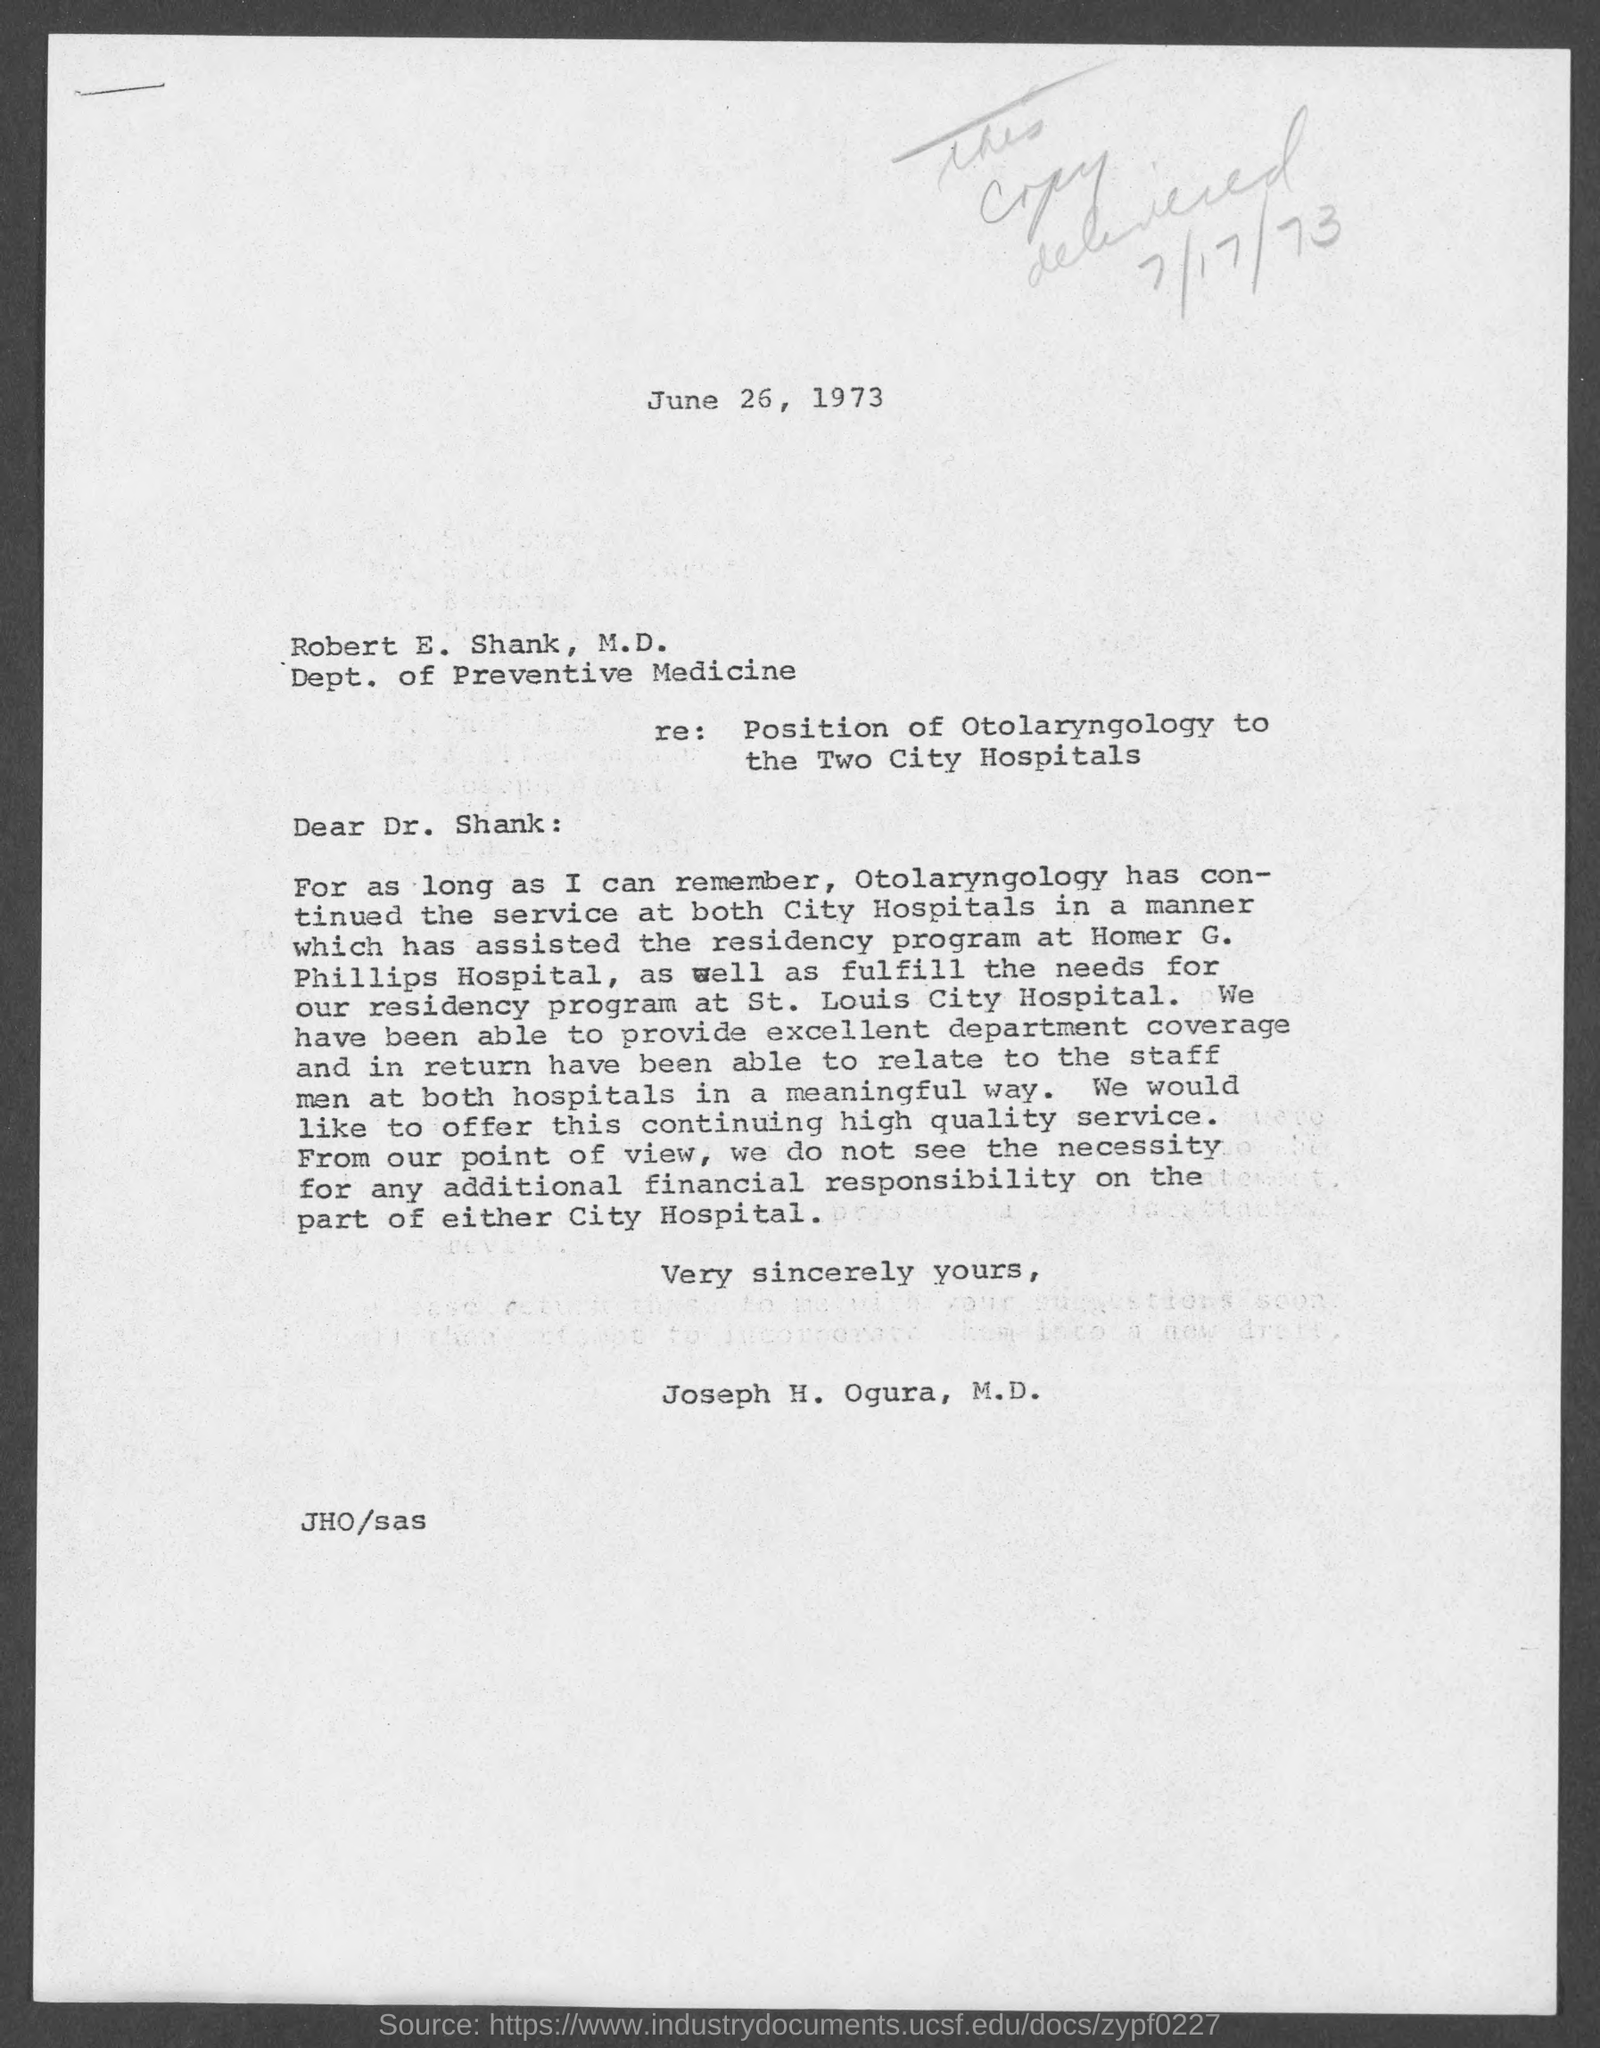Specify some key components in this picture. The issued date of this letter is June 26, 1973. The sender of the letter is Joseph H. Ogura, M.D. 